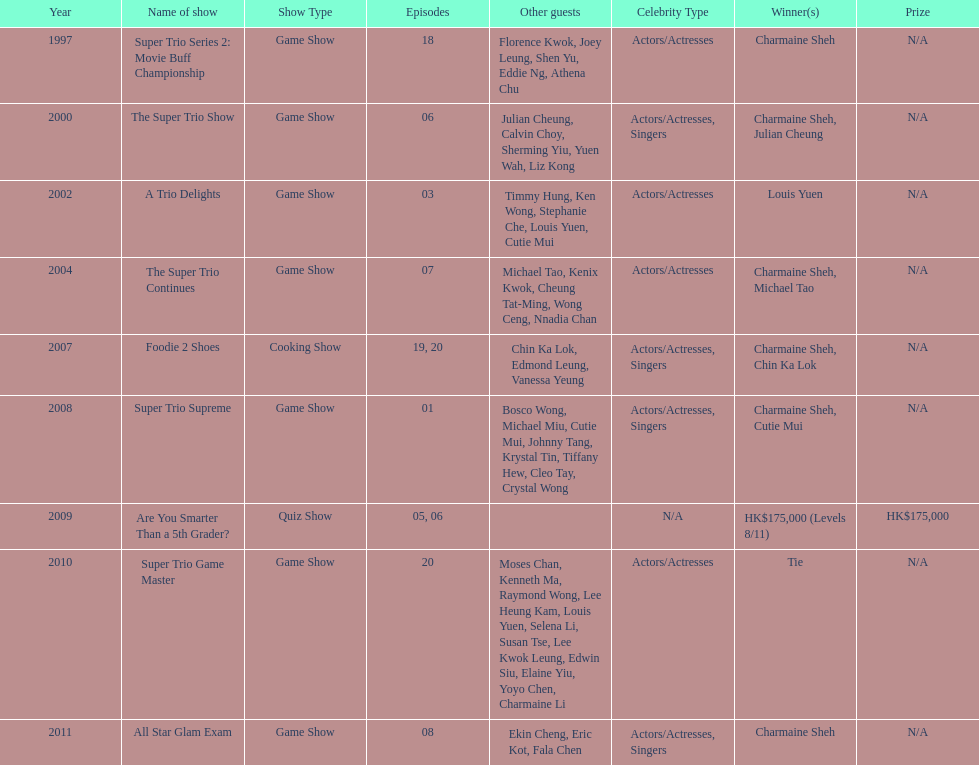In how many television series has charmaine sheh made appearances? 9. 